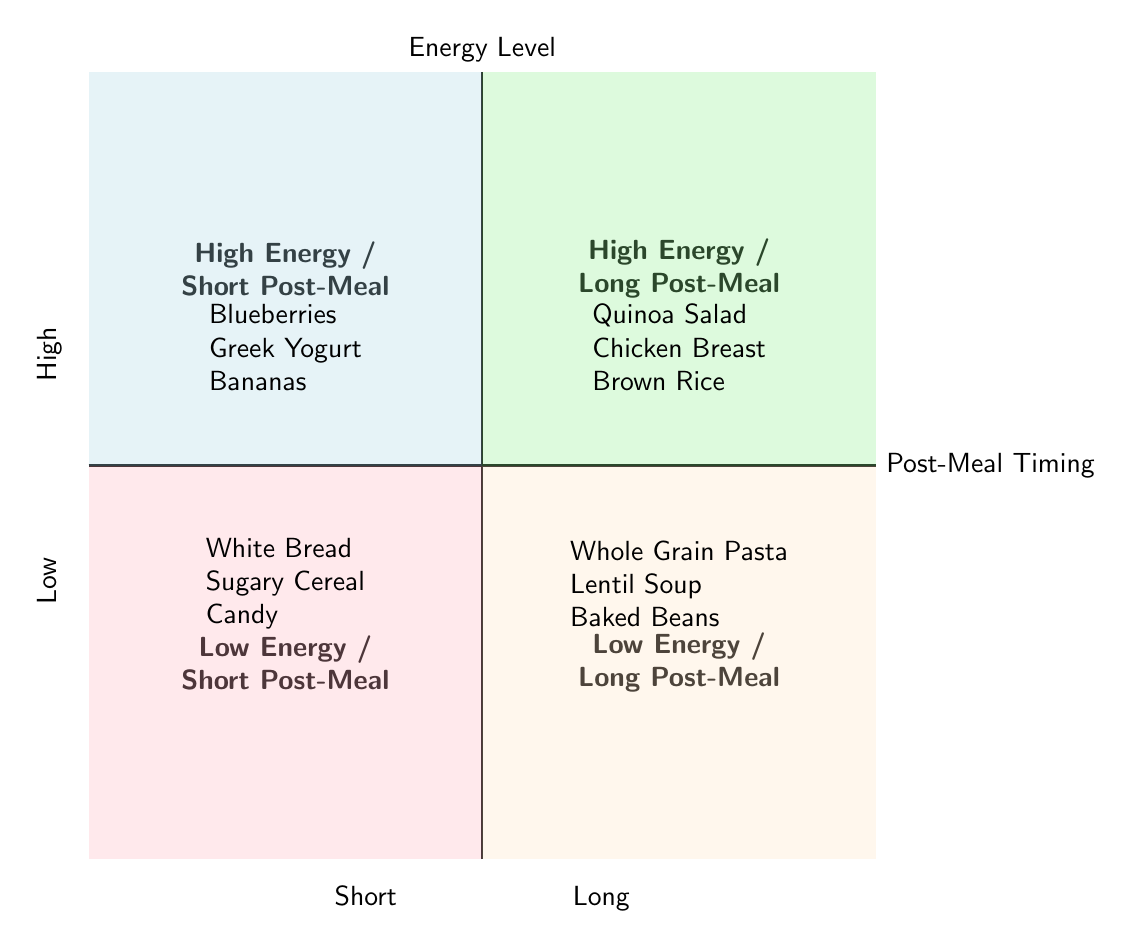What foods provide high energy with short post-meal timing? In the quadrant labeled "High Energy / Short Post-Meal Timing," the diagram lists three specific foods: Blueberries, Greek Yogurt, and Bananas.
Answer: Blueberries, Greek Yogurt, Bananas Which food is associated with low energy and long post-meal timing? The quadrant titled "Low Energy / Long Post-Meal Timing" contains three items: Whole Grain Pasta, Lentil Soup, and Baked Beans. These foods are characterized by being low energy after a longer post-meal waiting period.
Answer: Whole Grain Pasta How many types of food are listed in the "High Energy / Long Post-Meal Timing" quadrant? This quadrant includes three types of food, which are Quinoa Salad, Chicken Breast, and Brown Rice. Therefore, the count is straightforward.
Answer: 3 What is the type of food corresponding to low energy and short post-meal timing? The "Low Energy / Short Post-Meal Timing" quadrant provides three examples: White Bread, Sugary Cereal, and Candy. Thus, they exemplify low energy foods consumed shortly after a meal.
Answer: White Bread, Sugary Cereal, Candy Compare the energy levels of Quinoa Salad and White Bread. Quinoa Salad is placed in the "High Energy / Long Post-Meal Timing" quadrant, whereas White Bread is in the "Low Energy / Short Post-Meal Timing" quadrant. This comparison indicates that Quinoa Salad offers higher energy than White Bread, especially when considering the impact of timing.
Answer: Quinoa Salad is higher energy than White Bread What is the common characteristic of foods listed under "Low Energy / Long Post-Meal Timing"? The foods in this quadrant are typically more complex and nutritious options, such as Whole Grain Pasta, Lentil Soup, and Baked Beans, suggesting that they may take longer to digest and provide lower immediate energy.
Answer: They take longer to digest Which quadrant has the highest energy foods for short post-meal timing? The quadrant labeled "High Energy / Short Post-Meal Timing" stands out with its title indicating high energy foods consumed shortly after meals. The foods listed confirm this designation.
Answer: High Energy / Short Post-Meal Timing List a food that combines high energy and long post-meal timing. The quadrant "High Energy / Long Post-Meal Timing" includes Quinoa Salad, Chicken Breast, and Brown Rice. They demonstrate both high energy levels and longer digestive times.
Answer: Quinoa Salad 